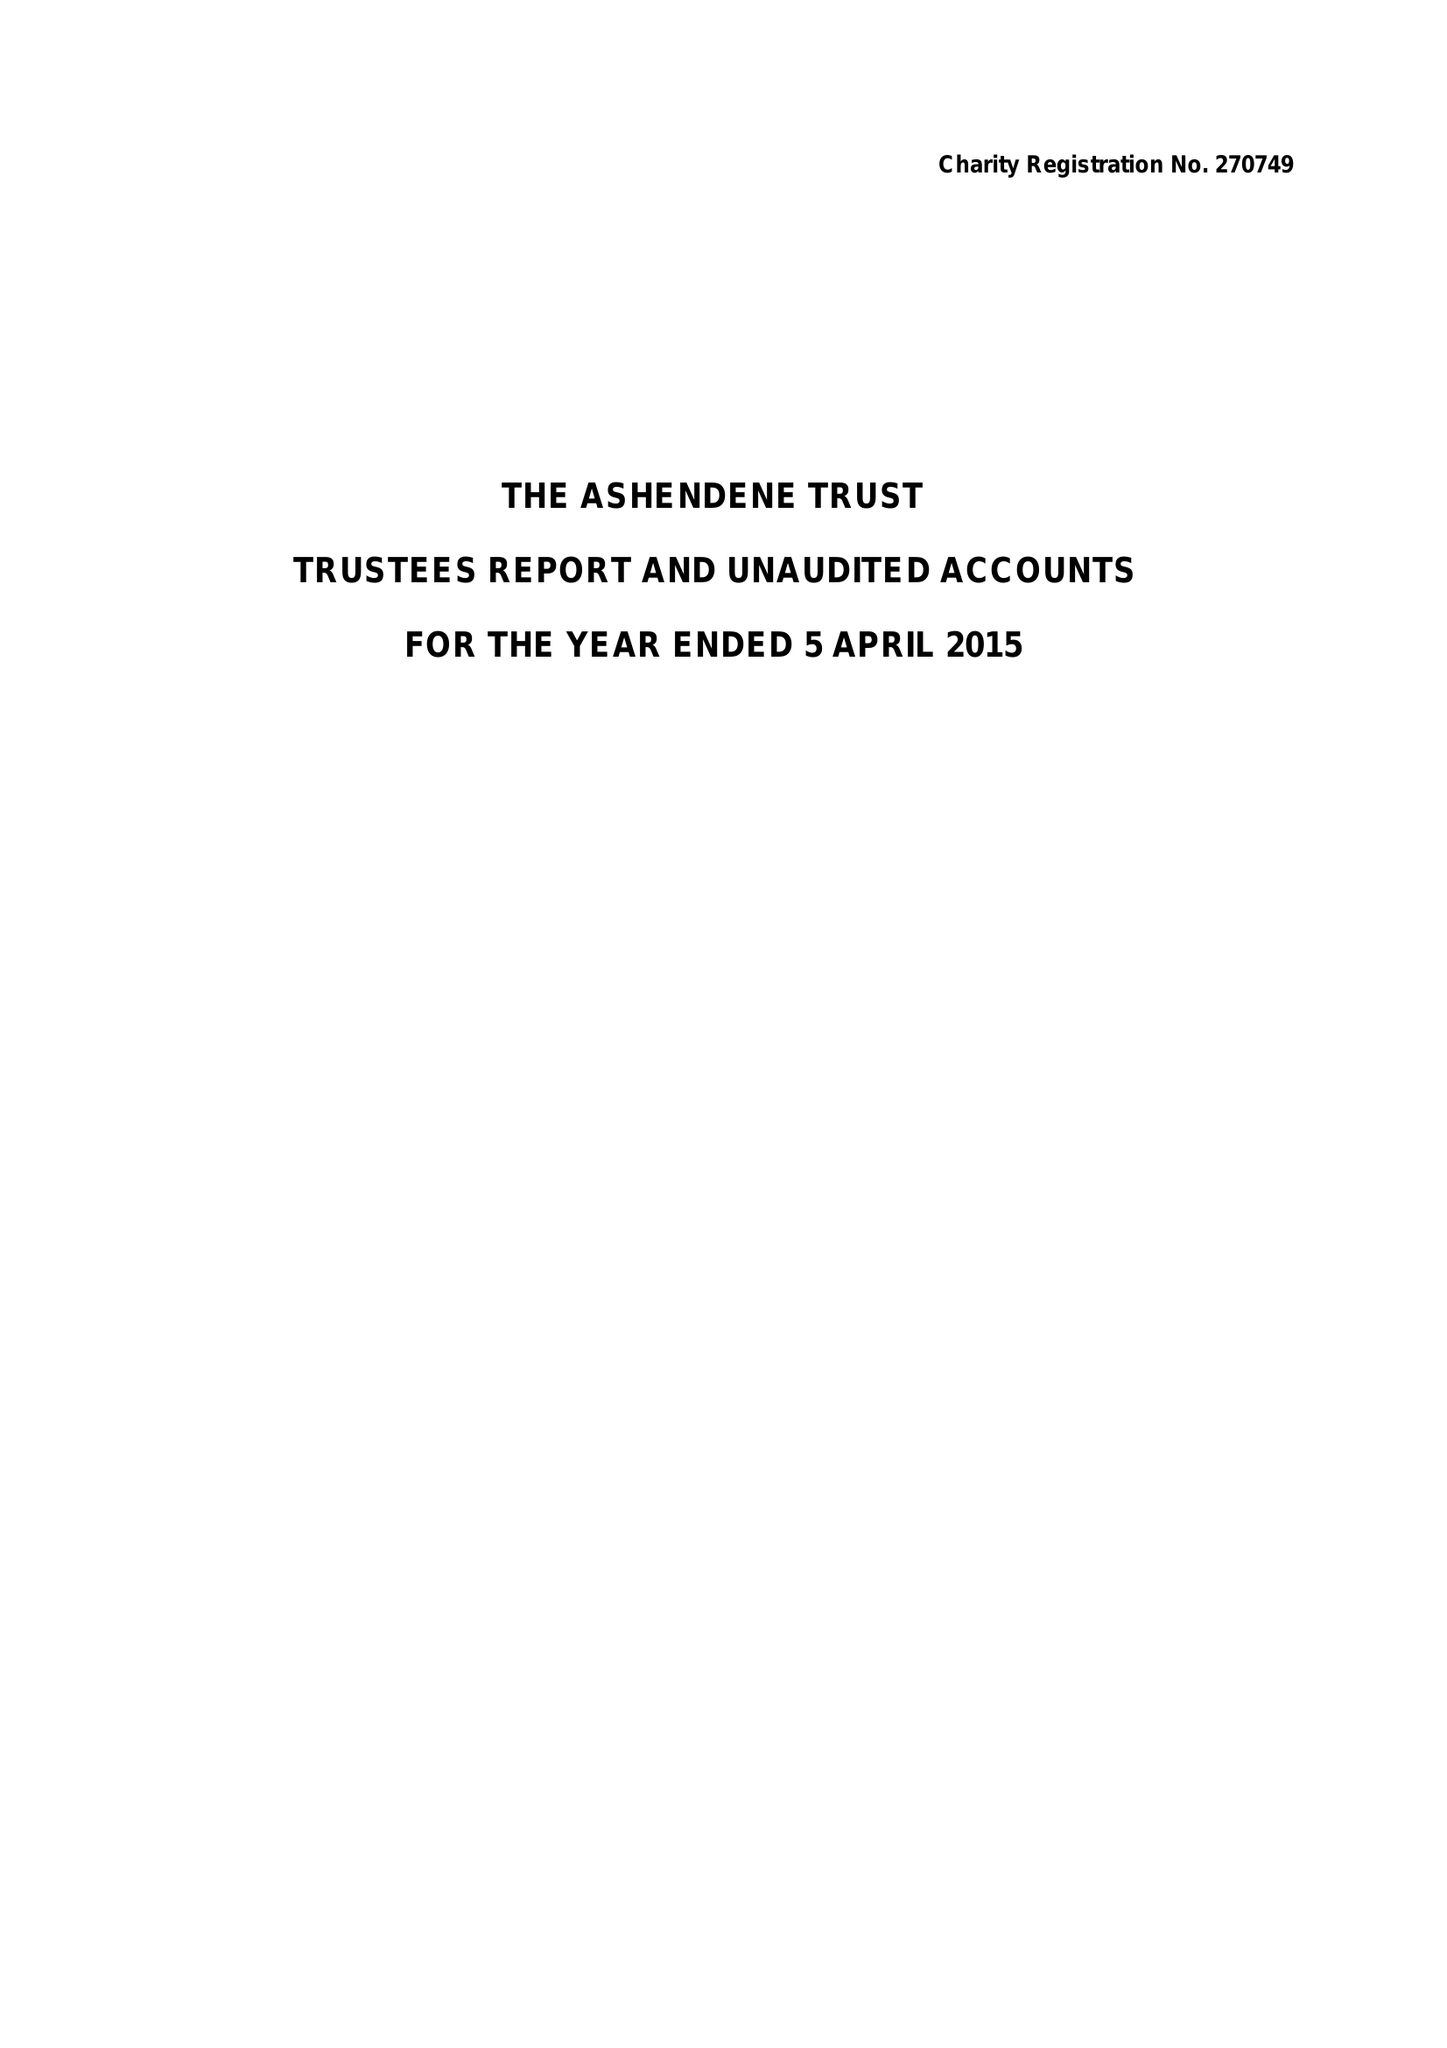What is the value for the address__postcode?
Answer the question using a single word or phrase. W1S 3ED 